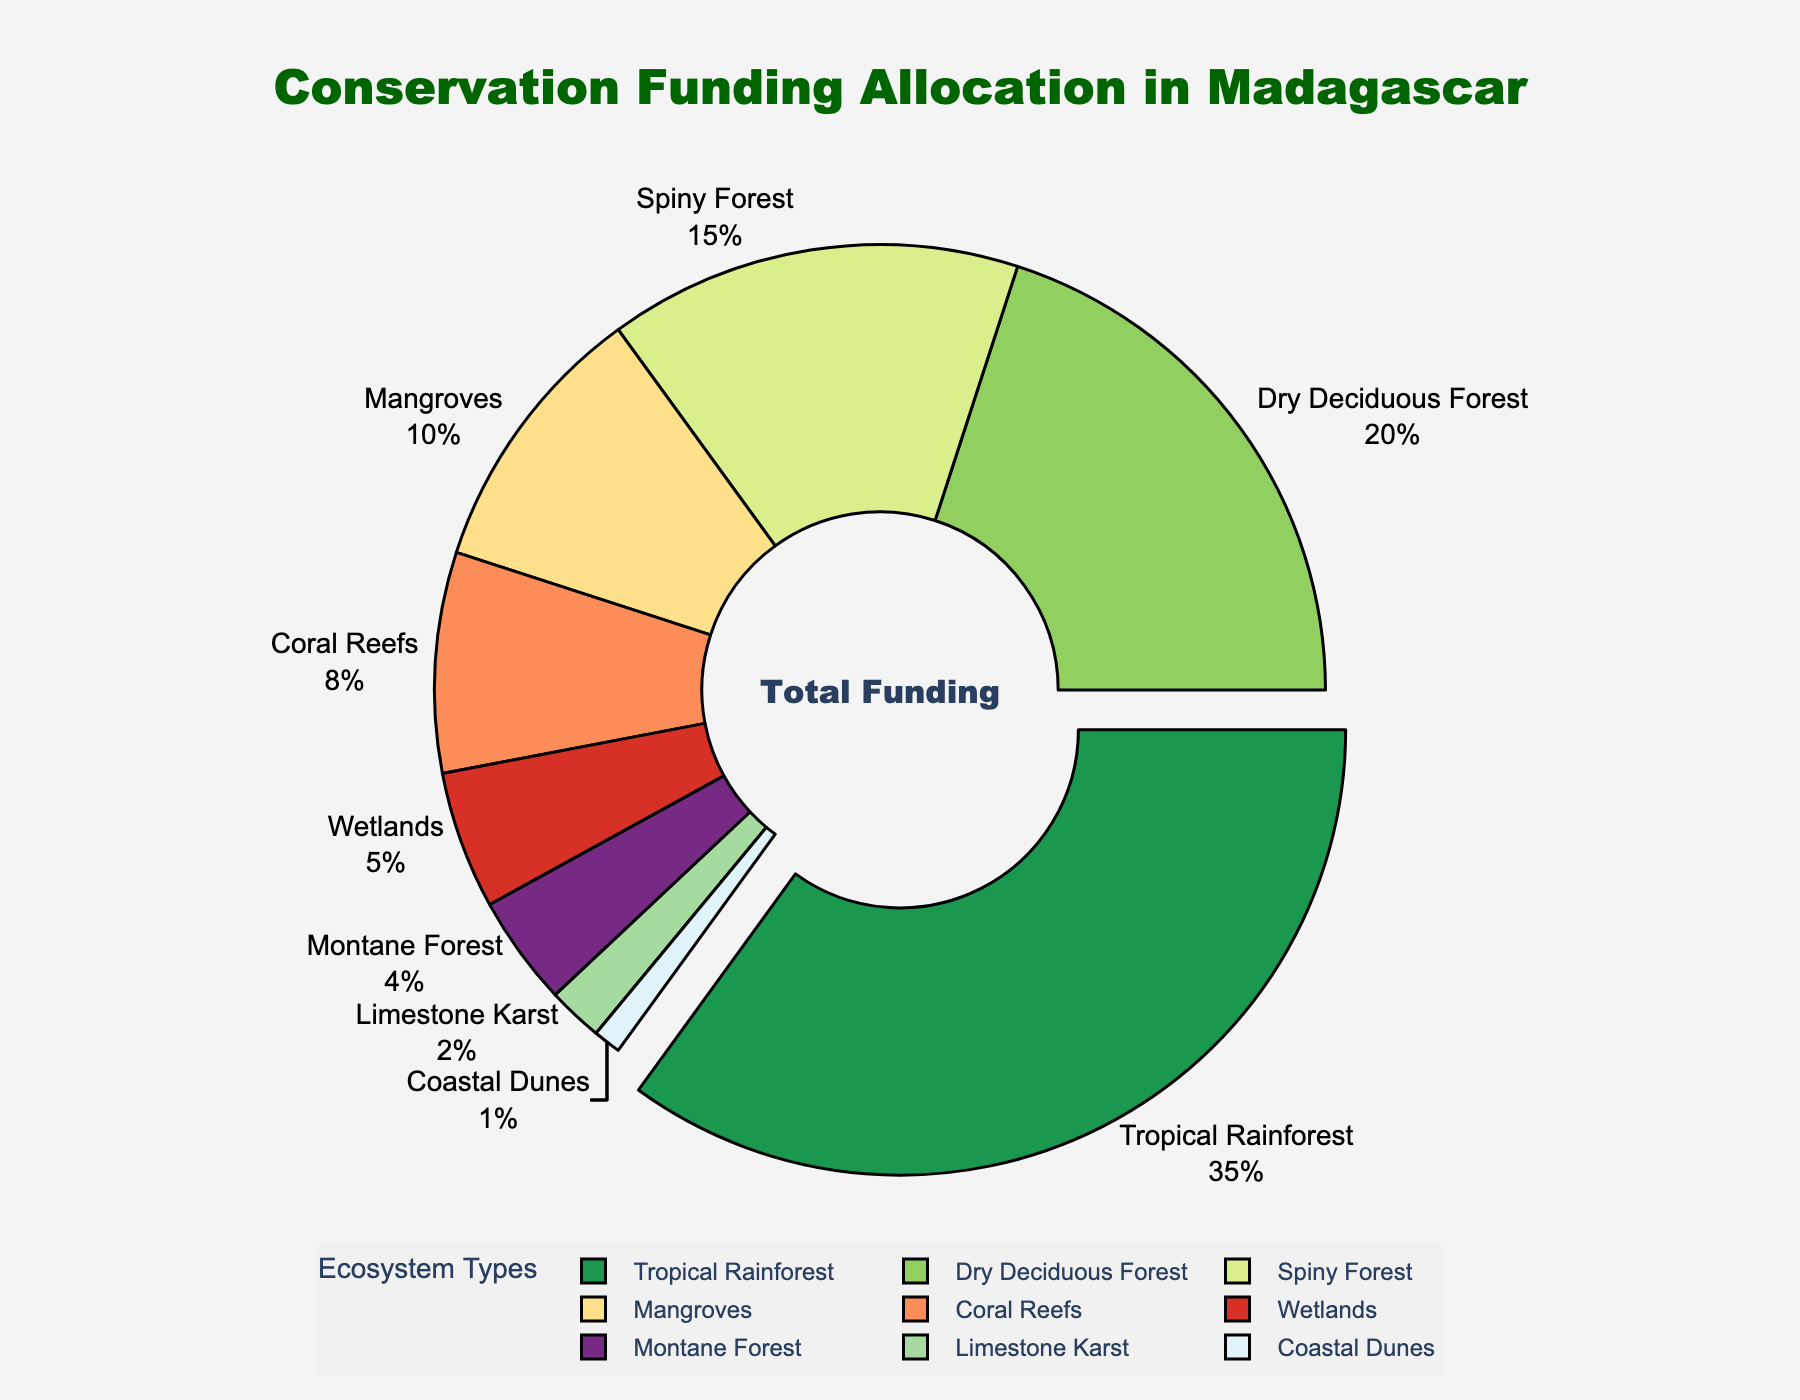What percentage of the funding is allocated to the Tropical Rainforest ecosystem? The chart shows the funding allocation percentages for different ecosystems. Locate the Tropical Rainforest segment and read its percentage label.
Answer: 35% Which ecosystem receives the least funding, and what is its percentage? Identify the segment with the smallest portion of the chart and read its label and percentage.
Answer: Coastal Dunes, 1% Compare the funding for Tropical Rainforest and Mangroves ecosystems. By how many percentage points is the Tropical Rainforest funding higher? Locate the percentages for Tropical Rainforest and Mangroves. Calculate the difference by subtracting Mangroves' percentage from Tropical Rainforest's percentage (35% - 10%).
Answer: 25% What is the total funding percentage for all forest ecosystems (Tropical Rainforest, Dry Deciduous Forest, Spiny Forest, and Montane Forest)? Sum the percentages of all forest ecosystems by adding their values (35% + 20% + 15% + 4%).
Answer: 74% Which three ecosystems receive more than 10% of the total funding, and what are their respective percentages? Identify the segments with percentages greater than 10% and list them with their values.
Answer: Tropical Rainforest (35%), Dry Deciduous Forest (20%), Spiny Forest (15%) Is the funding allocation for Coastal Dunes more than or less than the funding allocation for Limestone Karst? Compare the percentages for Coastal Dunes and Limestone Karst. Coastal Dunes is 1%, and Limestone Karst is 2%.
Answer: Less How does the funding percentage for Coral Reefs compare to that of Wetlands? Locate the segments for Coral Reefs and Wetlands. Coral Reefs have 8%, and Wetlands have 5%.
Answer: Coral Reefs > Wetlands By how many percentage points is the combined funding for Mangroves and Wetlands higher than for Coral Reefs? Add the percentages for Mangroves and Wetlands (10% + 5%). Subtract Coral Reefs' percentage from this sum (15% - 8%).
Answer: 7% What is the average funding percentage for Montane Forest and Limestone Karst ecosystems? Add the percentages for Montane Forest and Limestone Karst (4% + 2%) and divide by 2.
Answer: 3% Which ecosystem type has a segment that is visually pulled out from the center of the pie chart, and what does this indicate? Identify the segment that is separated from the pie chart. This segment is Tropical Rainforest, indicating it has the highest funding allocation.
Answer: Tropical Rainforest 